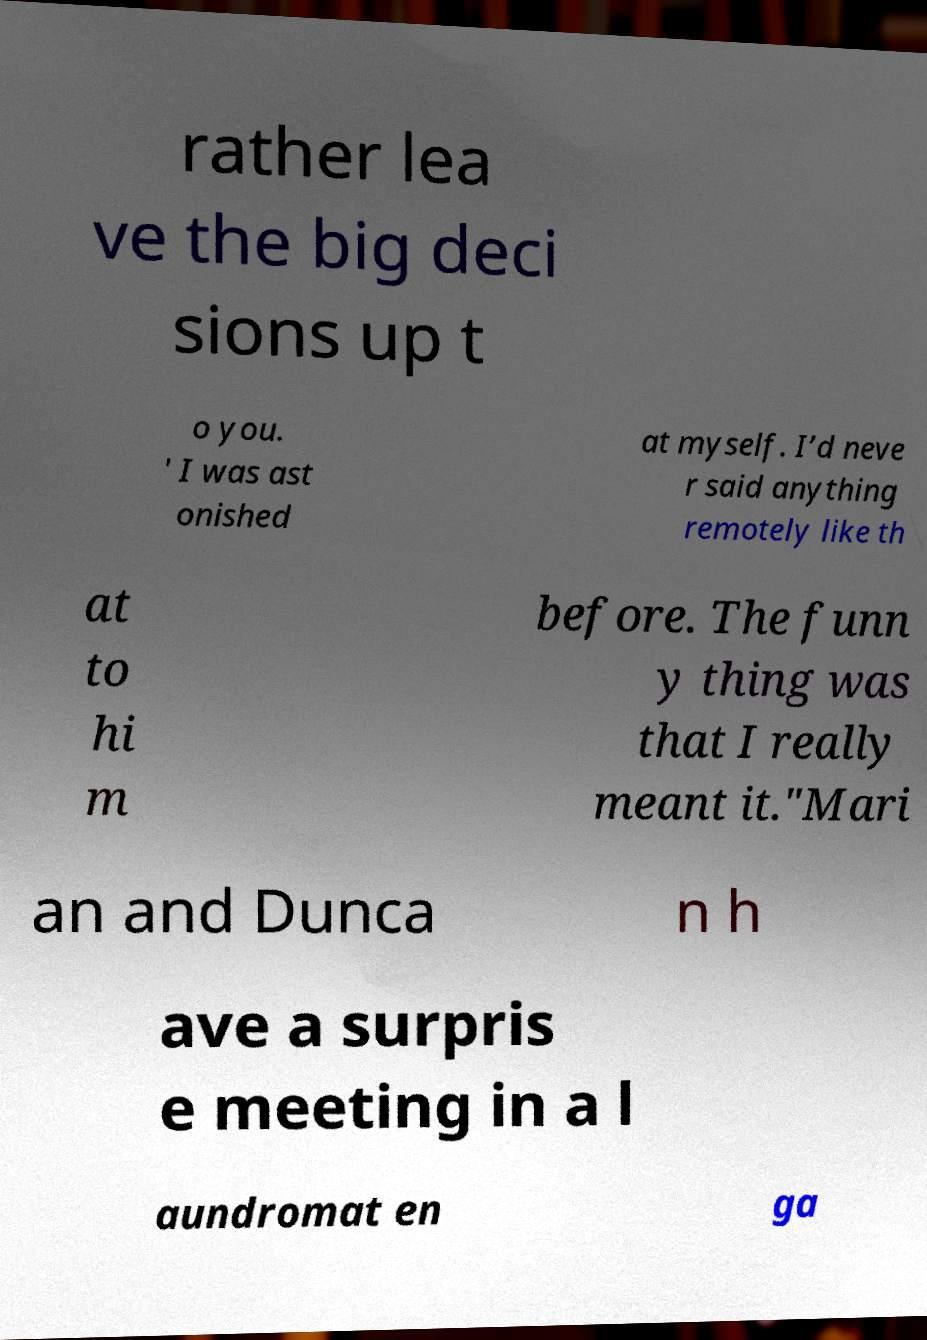Please read and relay the text visible in this image. What does it say? rather lea ve the big deci sions up t o you. ' I was ast onished at myself. I’d neve r said anything remotely like th at to hi m before. The funn y thing was that I really meant it."Mari an and Dunca n h ave a surpris e meeting in a l aundromat en ga 